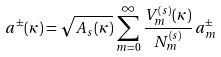<formula> <loc_0><loc_0><loc_500><loc_500>a ^ { \pm } ( \kappa ) = \sqrt { A _ { s } ( \kappa ) } \, \sum _ { m = 0 } ^ { \infty } \frac { V _ { m } ^ { ( s ) } ( \kappa ) } { N _ { m } ^ { ( s ) } } \, a _ { m } ^ { \pm }</formula> 